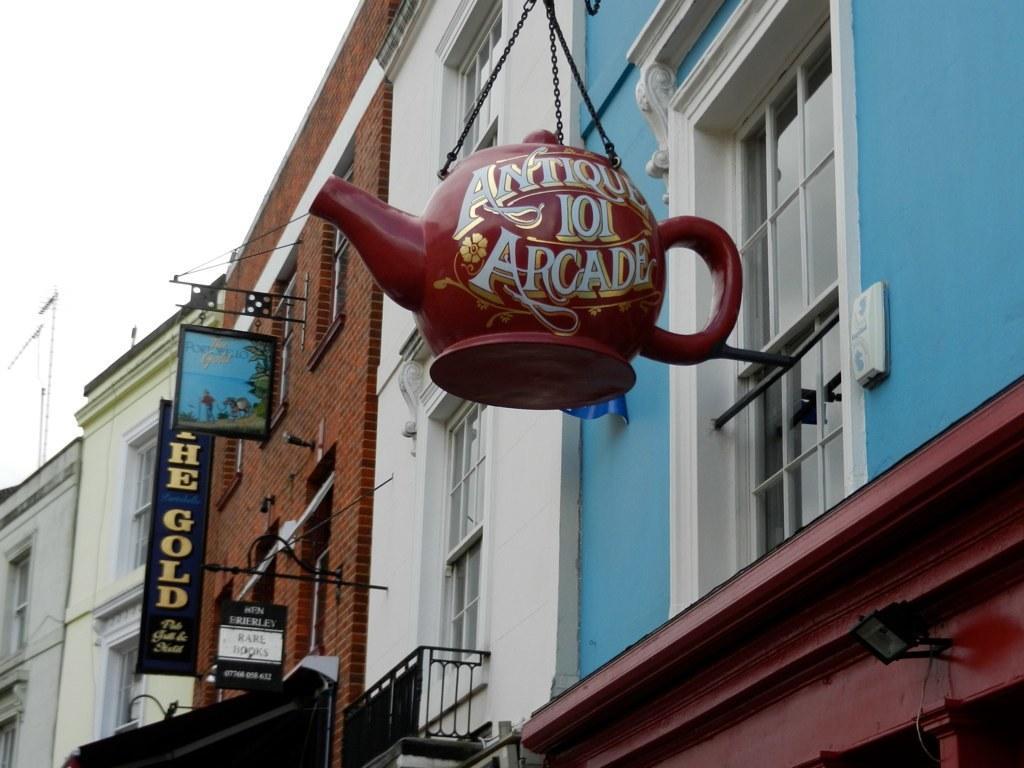In one or two sentences, can you explain what this image depicts? In this picture we can see there are buildings with windows, iron rods, boards, chains and a teapot shaped object. Behind the buildings there is the sky. 